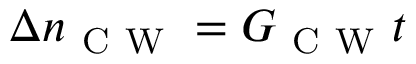<formula> <loc_0><loc_0><loc_500><loc_500>\Delta n _ { C W } = G _ { C W } t</formula> 